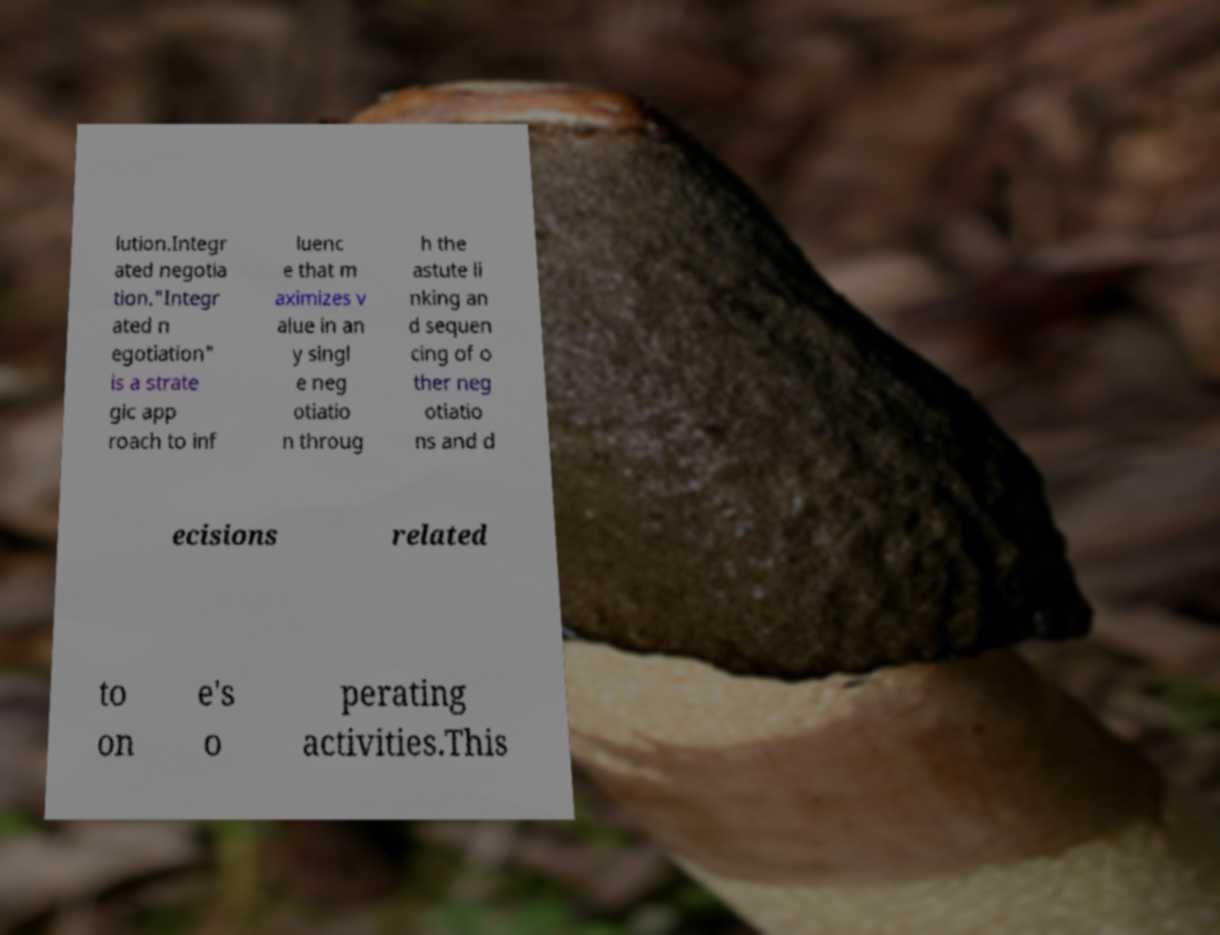Please identify and transcribe the text found in this image. lution.Integr ated negotia tion."Integr ated n egotiation" is a strate gic app roach to inf luenc e that m aximizes v alue in an y singl e neg otiatio n throug h the astute li nking an d sequen cing of o ther neg otiatio ns and d ecisions related to on e's o perating activities.This 